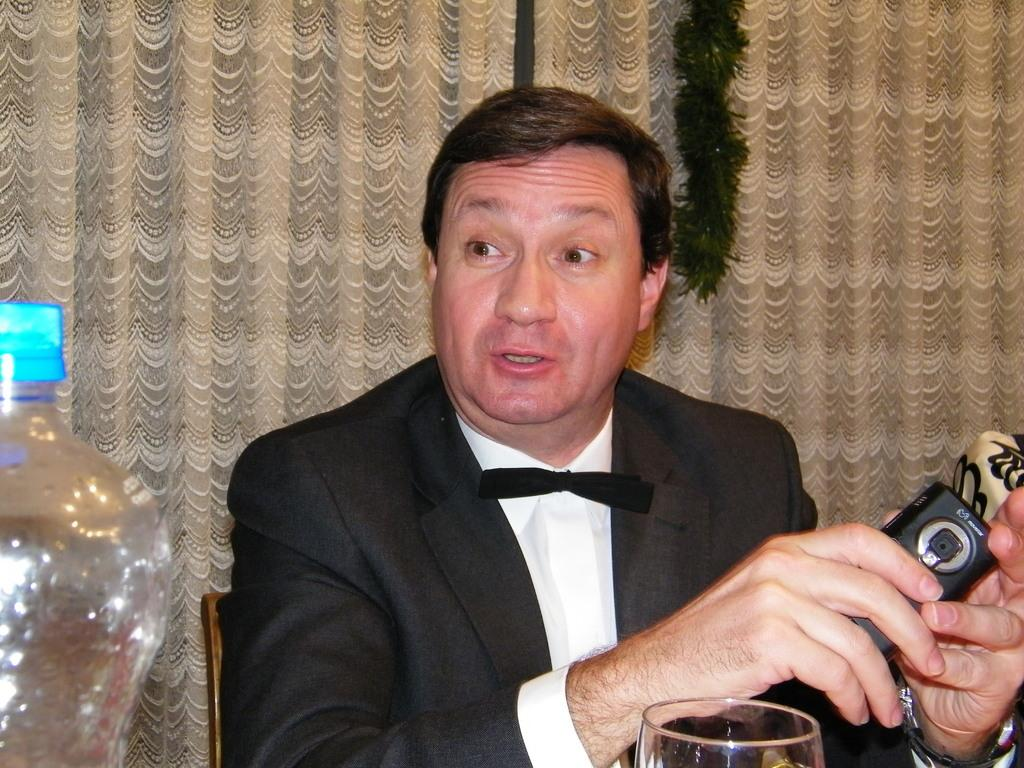What is the person in the image doing? The person is holding a mobile and talking. What can be seen in the left corner of the image? There is a bottle in the left corner of the image. What else is present in the image besides the person and the bottle? There is a glass in the image. What can be seen in the background of the image? There is a curtain in the background of the image. How many hens are visible in the image? There are no hens present in the image. What type of cent is used to measure the person's height in the image? There is no cent used to measure the person's height in the image, as it is not a relevant detail in the provided facts. 